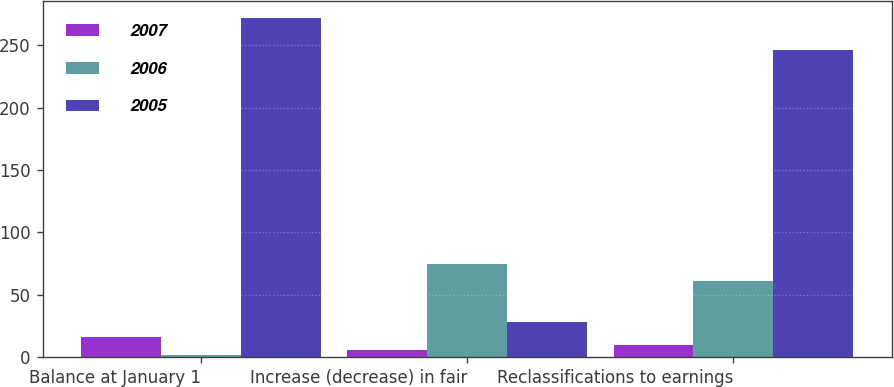<chart> <loc_0><loc_0><loc_500><loc_500><stacked_bar_chart><ecel><fcel>Balance at January 1<fcel>Increase (decrease) in fair<fcel>Reclassifications to earnings<nl><fcel>2007<fcel>16<fcel>6<fcel>10<nl><fcel>2006<fcel>2<fcel>75<fcel>61<nl><fcel>2005<fcel>272<fcel>28<fcel>246<nl></chart> 